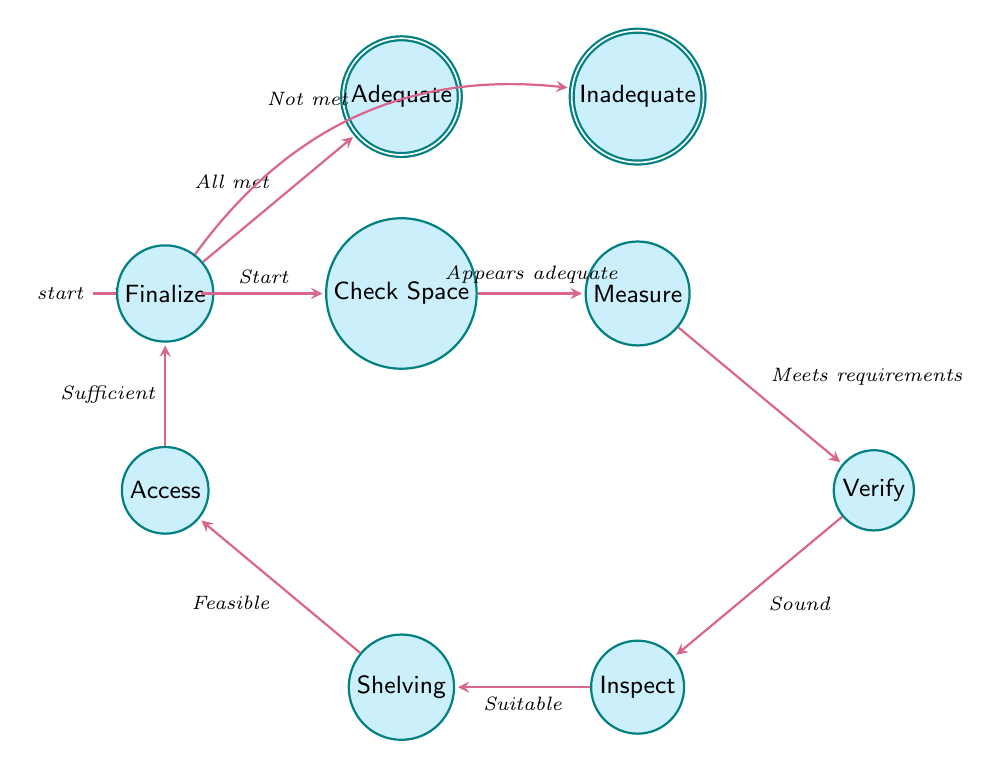What is the initial state of the evaluation process? The diagram starts with the "Start" state, which is the first position in the evaluation process as indicated by its status as the initial state.
Answer: Start How many states are present in the diagram? By counting the nodes in the diagram, we find there are a total of 10 states, including the initial and accepting states.
Answer: 10 What condition leads from "check for sufficient space" to "measure basement size"? The transition from "check for sufficient space" to "measure basement size" occurs when the condition "Space appears adequate" is met.
Answer: Space appears adequate In which state do you determine shelving requirements? Shelving requirements are determined in the "Determine Shelving Requirements" state, which follows the "Inspect Environmental Conditions" state in the flow of the evaluation process.
Answer: Determine Shelving Requirements What happens if one or more criteria are not met during the evaluation? If one or more criteria are not met, the process transitions from "Finalize Decision" to the "Inadequate" state, indicating that the storage space is not sufficient.
Answer: Inadequate What is the final decision if all criteria are met? If all criteria are met during the evaluation process, the final decision is to transition to the "Adequate" state, which confirms that the storage space is sufficient.
Answer: Adequate How many edges connect the "finalize decision" state to its outcome states? The "Finalize Decision" state connects to two outcome states, namely the "Adequate" and "Inadequate" states, representing possible final outcomes of the evaluation process.
Answer: 2 What is the condition required to evaluate accessibility? The condition required to proceed to the "Evaluate Accessibility" state is that "Shelving requirements are feasible," which must be fulfilled to access the next step in the evaluation.
Answer: Shelving requirements are feasible What indicates a successful evaluation of storage space? A successful evaluation is indicated by the transition from the "Finalize Decision" state to the "Adequate" state, which means all evaluation criteria have been successfully met.
Answer: All criteria met 